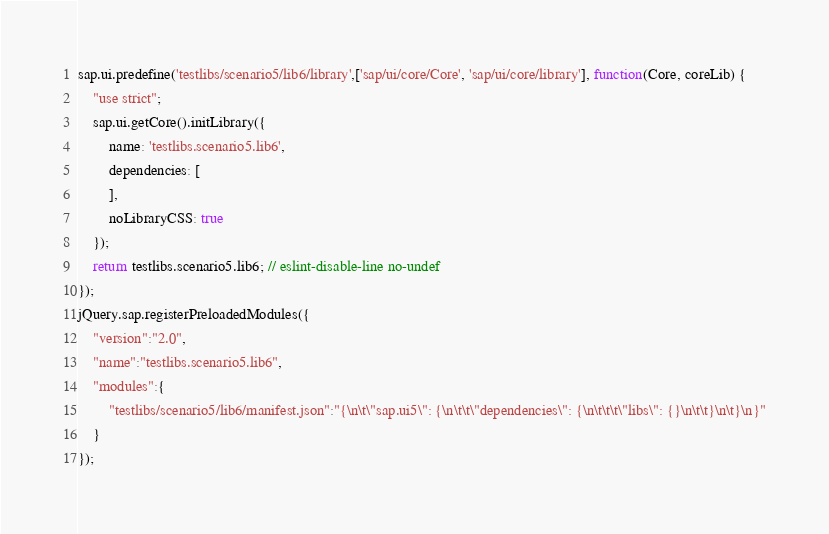Convert code to text. <code><loc_0><loc_0><loc_500><loc_500><_JavaScript_>sap.ui.predefine('testlibs/scenario5/lib6/library',['sap/ui/core/Core', 'sap/ui/core/library'], function(Core, coreLib) {
	"use strict";
	sap.ui.getCore().initLibrary({
		name: 'testlibs.scenario5.lib6',
		dependencies: [
		],
		noLibraryCSS: true
	});
	return testlibs.scenario5.lib6; // eslint-disable-line no-undef
});
jQuery.sap.registerPreloadedModules({
	"version":"2.0",
	"name":"testlibs.scenario5.lib6",
	"modules":{
		"testlibs/scenario5/lib6/manifest.json":"{\n\t\"sap.ui5\": {\n\t\t\"dependencies\": {\n\t\t\t\"libs\": {}\n\t\t}\n\t}\n}"
	}
});</code> 